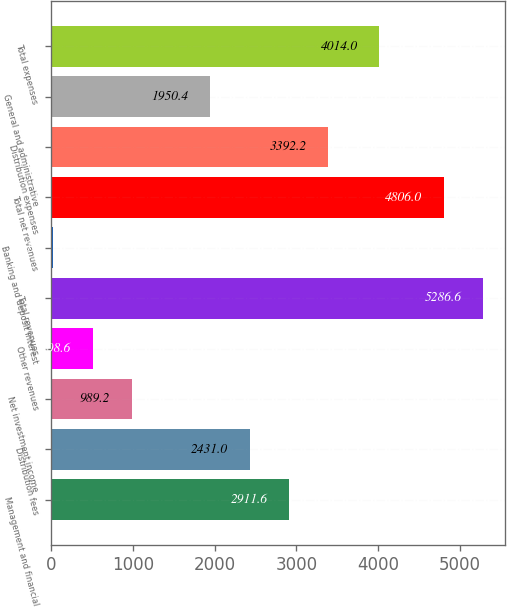Convert chart. <chart><loc_0><loc_0><loc_500><loc_500><bar_chart><fcel>Management and financial<fcel>Distribution fees<fcel>Net investment income<fcel>Other revenues<fcel>Total revenues<fcel>Banking and deposit interest<fcel>Total net revenues<fcel>Distribution expenses<fcel>General and administrative<fcel>Total expenses<nl><fcel>2911.6<fcel>2431<fcel>989.2<fcel>508.6<fcel>5286.6<fcel>28<fcel>4806<fcel>3392.2<fcel>1950.4<fcel>4014<nl></chart> 